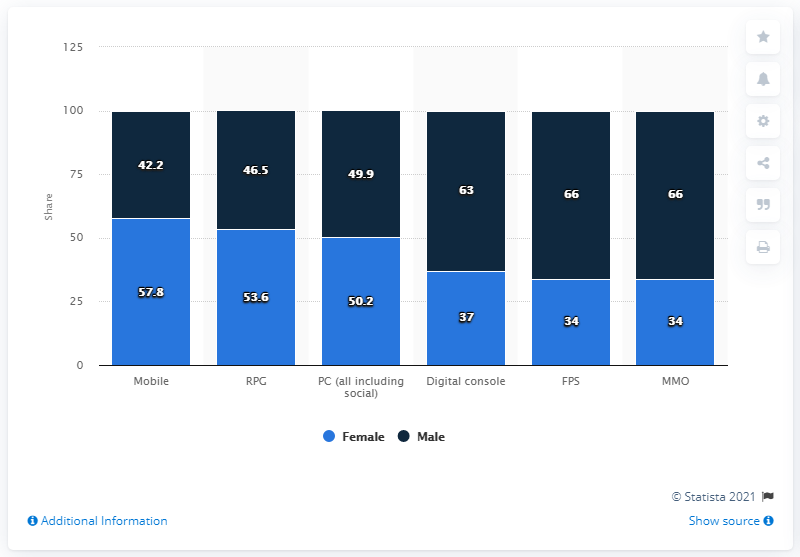Indicate a few pertinent items in this graphic. The total distribution by RPG is 100.1. The maximum number of male users and the minimum number of female users are 32. 